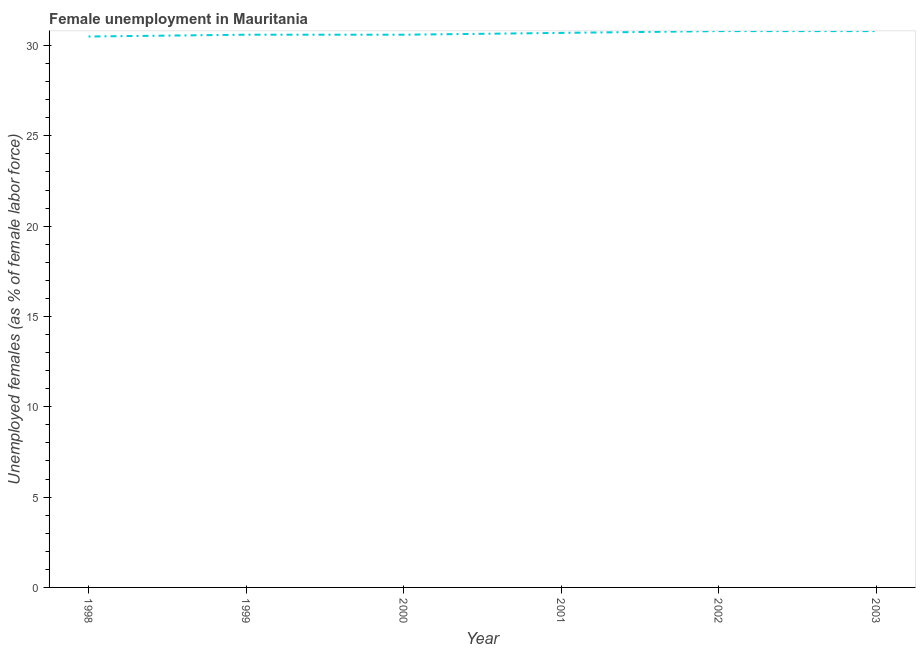What is the unemployed females population in 1999?
Ensure brevity in your answer.  30.6. Across all years, what is the maximum unemployed females population?
Provide a short and direct response. 30.8. Across all years, what is the minimum unemployed females population?
Give a very brief answer. 30.5. In which year was the unemployed females population minimum?
Your answer should be very brief. 1998. What is the sum of the unemployed females population?
Provide a short and direct response. 184. What is the difference between the unemployed females population in 2000 and 2001?
Provide a succinct answer. -0.1. What is the average unemployed females population per year?
Offer a very short reply. 30.67. What is the median unemployed females population?
Ensure brevity in your answer.  30.65. What is the ratio of the unemployed females population in 1999 to that in 2003?
Give a very brief answer. 0.99. Is the unemployed females population in 1999 less than that in 2000?
Your answer should be compact. No. Is the difference between the unemployed females population in 1999 and 2002 greater than the difference between any two years?
Offer a terse response. No. What is the difference between the highest and the second highest unemployed females population?
Offer a very short reply. 0. Is the sum of the unemployed females population in 1999 and 2003 greater than the maximum unemployed females population across all years?
Your response must be concise. Yes. What is the difference between the highest and the lowest unemployed females population?
Ensure brevity in your answer.  0.3. In how many years, is the unemployed females population greater than the average unemployed females population taken over all years?
Offer a terse response. 3. How many years are there in the graph?
Make the answer very short. 6. What is the difference between two consecutive major ticks on the Y-axis?
Your answer should be compact. 5. Are the values on the major ticks of Y-axis written in scientific E-notation?
Give a very brief answer. No. Does the graph contain any zero values?
Ensure brevity in your answer.  No. Does the graph contain grids?
Offer a terse response. No. What is the title of the graph?
Provide a succinct answer. Female unemployment in Mauritania. What is the label or title of the X-axis?
Offer a very short reply. Year. What is the label or title of the Y-axis?
Offer a very short reply. Unemployed females (as % of female labor force). What is the Unemployed females (as % of female labor force) of 1998?
Your answer should be very brief. 30.5. What is the Unemployed females (as % of female labor force) of 1999?
Make the answer very short. 30.6. What is the Unemployed females (as % of female labor force) in 2000?
Offer a terse response. 30.6. What is the Unemployed females (as % of female labor force) of 2001?
Offer a terse response. 30.7. What is the Unemployed females (as % of female labor force) in 2002?
Provide a short and direct response. 30.8. What is the Unemployed females (as % of female labor force) of 2003?
Ensure brevity in your answer.  30.8. What is the difference between the Unemployed females (as % of female labor force) in 1998 and 2000?
Give a very brief answer. -0.1. What is the difference between the Unemployed females (as % of female labor force) in 1998 and 2002?
Your answer should be compact. -0.3. What is the difference between the Unemployed females (as % of female labor force) in 1999 and 2001?
Offer a terse response. -0.1. What is the difference between the Unemployed females (as % of female labor force) in 1999 and 2002?
Your answer should be compact. -0.2. What is the difference between the Unemployed females (as % of female labor force) in 1999 and 2003?
Your answer should be compact. -0.2. What is the difference between the Unemployed females (as % of female labor force) in 2000 and 2002?
Your answer should be compact. -0.2. What is the difference between the Unemployed females (as % of female labor force) in 2001 and 2002?
Offer a terse response. -0.1. What is the ratio of the Unemployed females (as % of female labor force) in 1999 to that in 2001?
Your answer should be very brief. 1. What is the ratio of the Unemployed females (as % of female labor force) in 1999 to that in 2002?
Ensure brevity in your answer.  0.99. What is the ratio of the Unemployed females (as % of female labor force) in 1999 to that in 2003?
Keep it short and to the point. 0.99. What is the ratio of the Unemployed females (as % of female labor force) in 2000 to that in 2003?
Your response must be concise. 0.99. What is the ratio of the Unemployed females (as % of female labor force) in 2002 to that in 2003?
Your answer should be very brief. 1. 